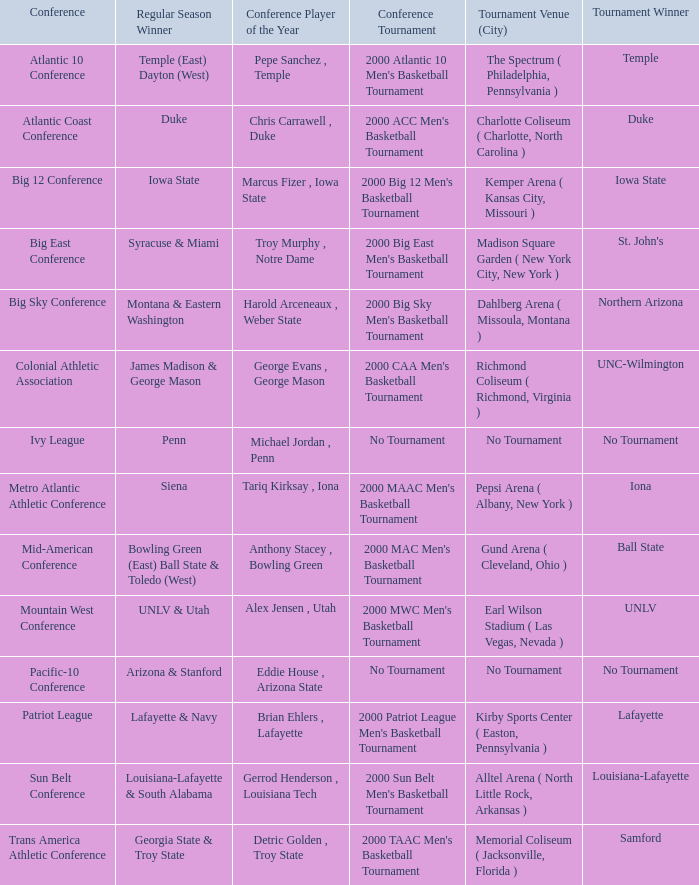Who is the regular season winner for the Ivy League conference? Penn. 